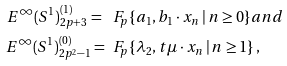<formula> <loc_0><loc_0><loc_500><loc_500>E ^ { \infty } ( S ^ { 1 } ) ^ { ( 1 ) } _ { 2 p + 3 } = \ & \ F _ { p } \{ a _ { 1 } , b _ { 1 } \cdot x _ { n } \, | \, n \geq 0 \} a n d \\ E ^ { \infty } ( S ^ { 1 } ) ^ { ( 0 ) } _ { 2 p ^ { 2 } - 1 } = \ & \ F _ { p } \{ \lambda _ { 2 } , t \mu \cdot x _ { n } \, | \, n \geq 1 \} \, , \\</formula> 